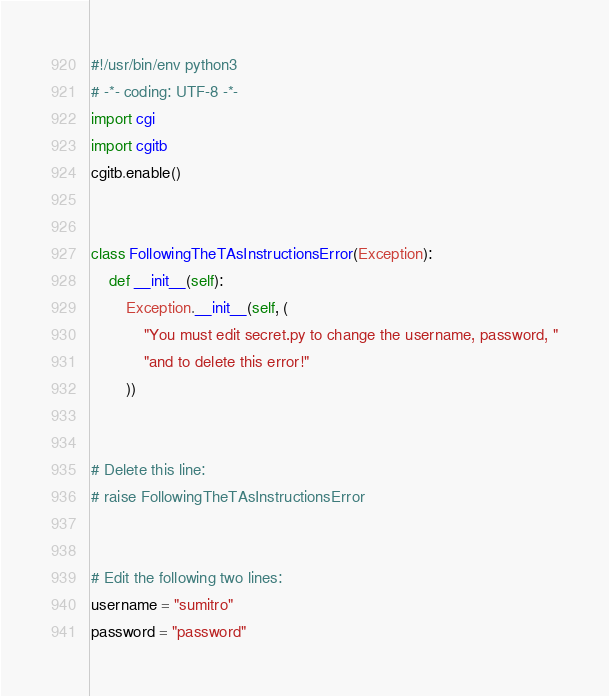<code> <loc_0><loc_0><loc_500><loc_500><_Python_>#!/usr/bin/env python3
# -*- coding: UTF-8 -*-
import cgi
import cgitb
cgitb.enable()


class FollowingTheTAsInstructionsError(Exception):
    def __init__(self):
        Exception.__init__(self, (
            "You must edit secret.py to change the username, password, "
            "and to delete this error!"
        ))


# Delete this line:
# raise FollowingTheTAsInstructionsError


# Edit the following two lines:
username = "sumitro"
password = "password"
</code> 